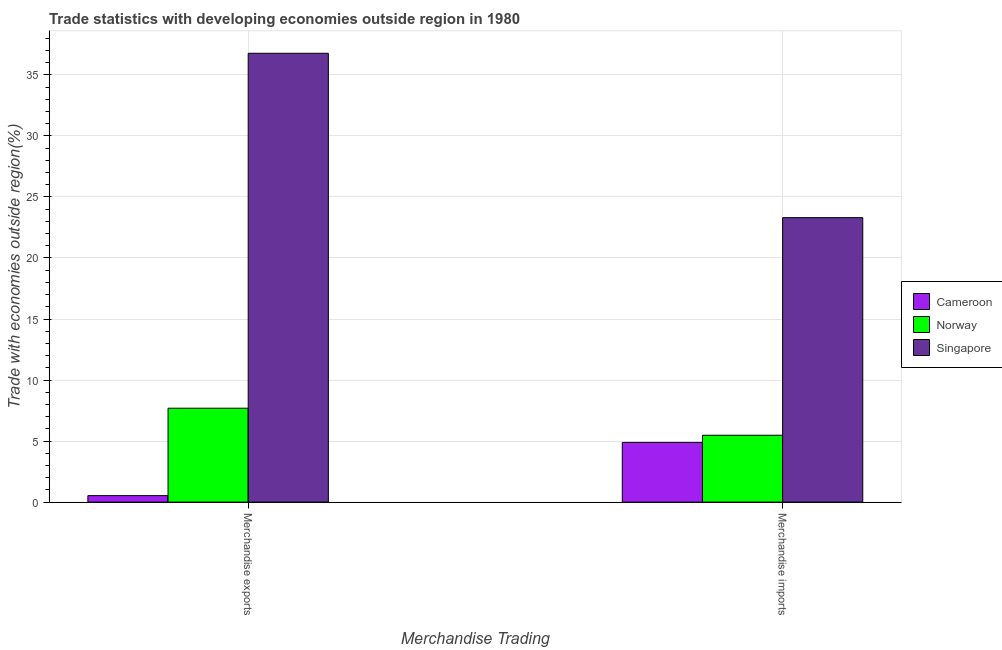What is the label of the 1st group of bars from the left?
Provide a short and direct response. Merchandise exports. What is the merchandise imports in Cameroon?
Keep it short and to the point. 4.89. Across all countries, what is the maximum merchandise exports?
Ensure brevity in your answer.  36.77. Across all countries, what is the minimum merchandise imports?
Your answer should be compact. 4.89. In which country was the merchandise imports maximum?
Offer a terse response. Singapore. In which country was the merchandise exports minimum?
Ensure brevity in your answer.  Cameroon. What is the total merchandise imports in the graph?
Give a very brief answer. 33.68. What is the difference between the merchandise imports in Cameroon and that in Norway?
Give a very brief answer. -0.59. What is the difference between the merchandise imports in Norway and the merchandise exports in Singapore?
Offer a terse response. -31.29. What is the average merchandise imports per country?
Provide a short and direct response. 11.23. What is the difference between the merchandise exports and merchandise imports in Cameroon?
Keep it short and to the point. -4.36. In how many countries, is the merchandise exports greater than 29 %?
Give a very brief answer. 1. What is the ratio of the merchandise imports in Norway to that in Singapore?
Your answer should be compact. 0.24. What does the 2nd bar from the left in Merchandise exports represents?
Provide a short and direct response. Norway. What does the 2nd bar from the right in Merchandise exports represents?
Ensure brevity in your answer.  Norway. How many bars are there?
Your answer should be very brief. 6. Are all the bars in the graph horizontal?
Keep it short and to the point. No. How many countries are there in the graph?
Offer a terse response. 3. Are the values on the major ticks of Y-axis written in scientific E-notation?
Provide a short and direct response. No. Does the graph contain any zero values?
Give a very brief answer. No. Where does the legend appear in the graph?
Offer a very short reply. Center right. How are the legend labels stacked?
Give a very brief answer. Vertical. What is the title of the graph?
Give a very brief answer. Trade statistics with developing economies outside region in 1980. Does "Middle East & North Africa (developing only)" appear as one of the legend labels in the graph?
Offer a terse response. No. What is the label or title of the X-axis?
Offer a terse response. Merchandise Trading. What is the label or title of the Y-axis?
Give a very brief answer. Trade with economies outside region(%). What is the Trade with economies outside region(%) of Cameroon in Merchandise exports?
Provide a succinct answer. 0.53. What is the Trade with economies outside region(%) in Norway in Merchandise exports?
Provide a short and direct response. 7.69. What is the Trade with economies outside region(%) in Singapore in Merchandise exports?
Keep it short and to the point. 36.77. What is the Trade with economies outside region(%) in Cameroon in Merchandise imports?
Offer a terse response. 4.89. What is the Trade with economies outside region(%) of Norway in Merchandise imports?
Your response must be concise. 5.48. What is the Trade with economies outside region(%) of Singapore in Merchandise imports?
Your answer should be very brief. 23.3. Across all Merchandise Trading, what is the maximum Trade with economies outside region(%) of Cameroon?
Your response must be concise. 4.89. Across all Merchandise Trading, what is the maximum Trade with economies outside region(%) of Norway?
Give a very brief answer. 7.69. Across all Merchandise Trading, what is the maximum Trade with economies outside region(%) of Singapore?
Provide a short and direct response. 36.77. Across all Merchandise Trading, what is the minimum Trade with economies outside region(%) in Cameroon?
Keep it short and to the point. 0.53. Across all Merchandise Trading, what is the minimum Trade with economies outside region(%) in Norway?
Your answer should be very brief. 5.48. Across all Merchandise Trading, what is the minimum Trade with economies outside region(%) in Singapore?
Your answer should be compact. 23.3. What is the total Trade with economies outside region(%) of Cameroon in the graph?
Ensure brevity in your answer.  5.42. What is the total Trade with economies outside region(%) of Norway in the graph?
Your response must be concise. 13.17. What is the total Trade with economies outside region(%) of Singapore in the graph?
Provide a short and direct response. 60.08. What is the difference between the Trade with economies outside region(%) of Cameroon in Merchandise exports and that in Merchandise imports?
Make the answer very short. -4.36. What is the difference between the Trade with economies outside region(%) of Norway in Merchandise exports and that in Merchandise imports?
Keep it short and to the point. 2.21. What is the difference between the Trade with economies outside region(%) in Singapore in Merchandise exports and that in Merchandise imports?
Give a very brief answer. 13.47. What is the difference between the Trade with economies outside region(%) in Cameroon in Merchandise exports and the Trade with economies outside region(%) in Norway in Merchandise imports?
Provide a succinct answer. -4.95. What is the difference between the Trade with economies outside region(%) of Cameroon in Merchandise exports and the Trade with economies outside region(%) of Singapore in Merchandise imports?
Offer a terse response. -22.77. What is the difference between the Trade with economies outside region(%) in Norway in Merchandise exports and the Trade with economies outside region(%) in Singapore in Merchandise imports?
Your response must be concise. -15.61. What is the average Trade with economies outside region(%) in Cameroon per Merchandise Trading?
Your answer should be compact. 2.71. What is the average Trade with economies outside region(%) of Norway per Merchandise Trading?
Your answer should be compact. 6.59. What is the average Trade with economies outside region(%) in Singapore per Merchandise Trading?
Give a very brief answer. 30.04. What is the difference between the Trade with economies outside region(%) of Cameroon and Trade with economies outside region(%) of Norway in Merchandise exports?
Make the answer very short. -7.16. What is the difference between the Trade with economies outside region(%) of Cameroon and Trade with economies outside region(%) of Singapore in Merchandise exports?
Give a very brief answer. -36.24. What is the difference between the Trade with economies outside region(%) in Norway and Trade with economies outside region(%) in Singapore in Merchandise exports?
Your answer should be very brief. -29.08. What is the difference between the Trade with economies outside region(%) of Cameroon and Trade with economies outside region(%) of Norway in Merchandise imports?
Offer a terse response. -0.59. What is the difference between the Trade with economies outside region(%) of Cameroon and Trade with economies outside region(%) of Singapore in Merchandise imports?
Give a very brief answer. -18.41. What is the difference between the Trade with economies outside region(%) in Norway and Trade with economies outside region(%) in Singapore in Merchandise imports?
Ensure brevity in your answer.  -17.83. What is the ratio of the Trade with economies outside region(%) in Cameroon in Merchandise exports to that in Merchandise imports?
Keep it short and to the point. 0.11. What is the ratio of the Trade with economies outside region(%) of Norway in Merchandise exports to that in Merchandise imports?
Provide a succinct answer. 1.4. What is the ratio of the Trade with economies outside region(%) of Singapore in Merchandise exports to that in Merchandise imports?
Your response must be concise. 1.58. What is the difference between the highest and the second highest Trade with economies outside region(%) in Cameroon?
Keep it short and to the point. 4.36. What is the difference between the highest and the second highest Trade with economies outside region(%) of Norway?
Give a very brief answer. 2.21. What is the difference between the highest and the second highest Trade with economies outside region(%) in Singapore?
Your answer should be compact. 13.47. What is the difference between the highest and the lowest Trade with economies outside region(%) in Cameroon?
Give a very brief answer. 4.36. What is the difference between the highest and the lowest Trade with economies outside region(%) in Norway?
Give a very brief answer. 2.21. What is the difference between the highest and the lowest Trade with economies outside region(%) in Singapore?
Your answer should be very brief. 13.47. 